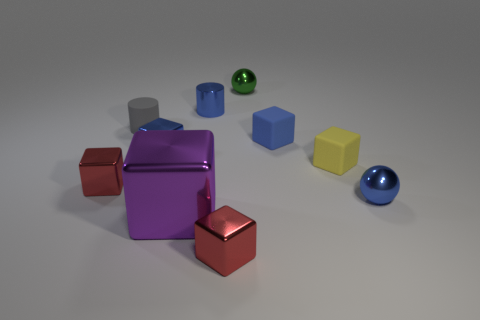Subtract 3 cubes. How many cubes are left? 3 Subtract all blue blocks. How many blocks are left? 4 Subtract all purple cubes. How many cubes are left? 5 Subtract all brown cubes. Subtract all yellow cylinders. How many cubes are left? 6 Subtract all blocks. How many objects are left? 4 Add 3 small blue cylinders. How many small blue cylinders exist? 4 Subtract 0 red balls. How many objects are left? 10 Subtract all purple metallic cubes. Subtract all gray objects. How many objects are left? 8 Add 6 green spheres. How many green spheres are left? 7 